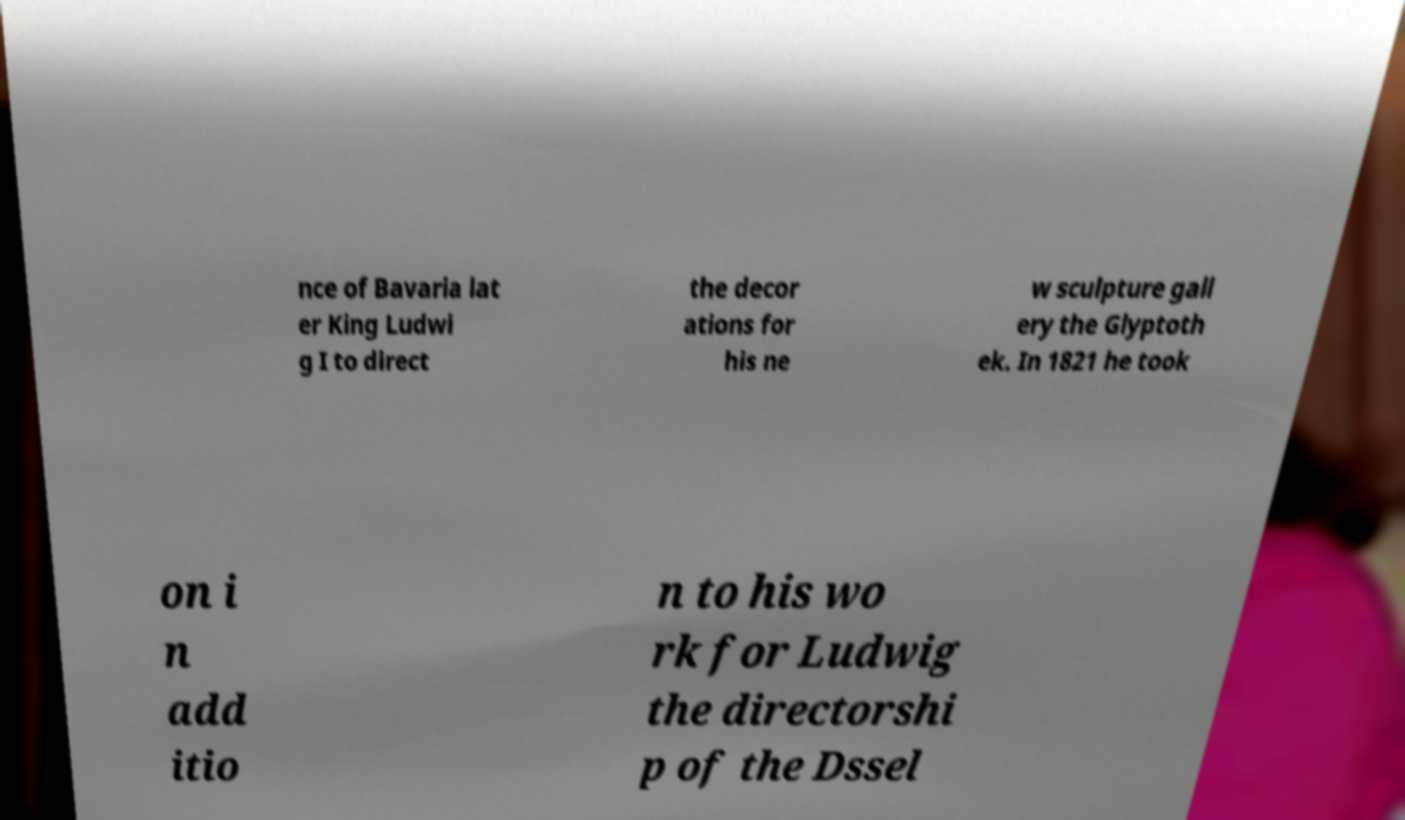Can you accurately transcribe the text from the provided image for me? nce of Bavaria lat er King Ludwi g I to direct the decor ations for his ne w sculpture gall ery the Glyptoth ek. In 1821 he took on i n add itio n to his wo rk for Ludwig the directorshi p of the Dssel 